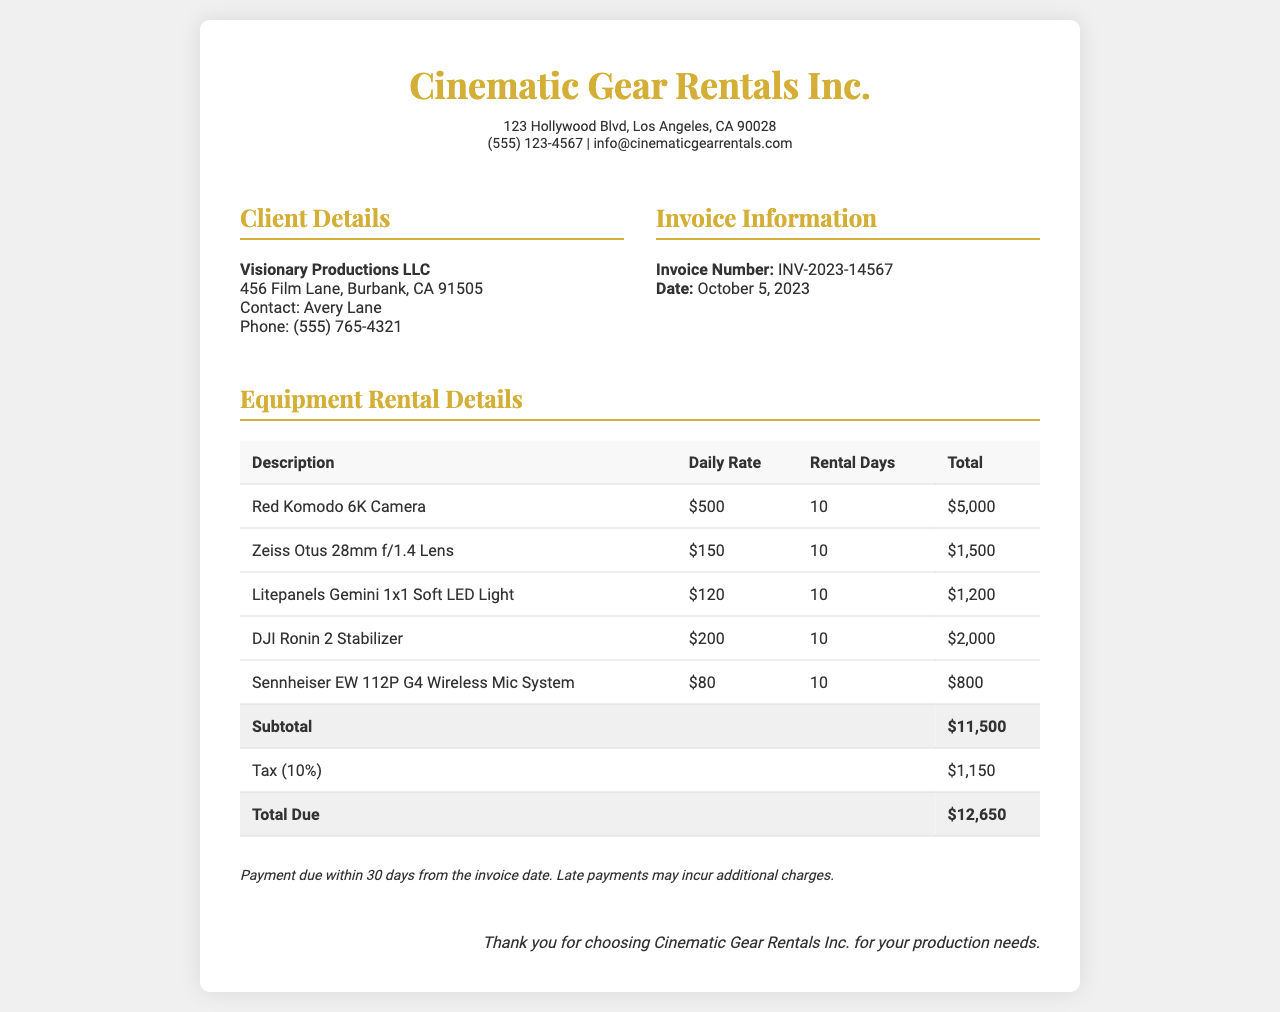what is the invoice number? The invoice number is a unique identifier for this transaction, which is explicitly mentioned in the document.
Answer: INV-2023-14567 who is the client? The client's name is provided in the client information section and identifies the entity renting the equipment.
Answer: Visionary Productions LLC what is the daily rate for the Red Komodo 6K Camera? The daily rate for the specific camera is listed in the equipment rental details table, directly showing the cost for one day of rental.
Answer: $500 how much is the total due? The total due is calculated at the end of the invoice, summarizing all charges and taxes applicable.
Answer: $12,650 what is the rental period for all equipment? The rental period specifies how many days the equipment will be rented, and it is consistent across all items in the invoice.
Answer: 10 what is the subtotal of the equipment rental? The subtotal indicates the total cost of the equipment before tax and is shown clearly in the document.
Answer: $11,500 which company issued this invoice? The issuing company's name is prominently displayed at the top of the invoice, indicating the source of the rental services.
Answer: Cinematic Gear Rentals Inc what is the tax percentage applied? The tax percentage is stated within the invoice and applies to the total charges, demonstrating the tax computation on rentals.
Answer: 10% 